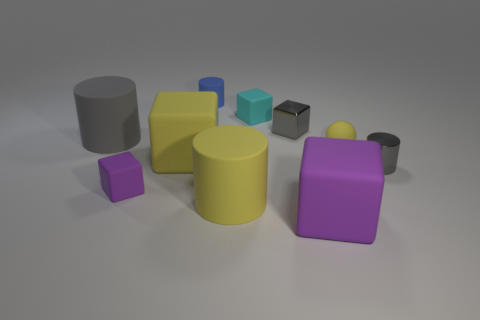How many matte objects have the same color as the shiny block?
Offer a terse response. 1. How many objects are small gray things on the right side of the yellow block or yellow blocks behind the large purple matte block?
Your answer should be very brief. 3. Are there fewer tiny blue rubber cylinders that are on the right side of the big purple cube than small cylinders?
Provide a succinct answer. Yes. Is there a cube of the same size as the blue cylinder?
Ensure brevity in your answer.  Yes. The metallic cylinder has what color?
Keep it short and to the point. Gray. Do the gray matte thing and the yellow cylinder have the same size?
Give a very brief answer. Yes. How many things are either red shiny things or yellow matte objects?
Ensure brevity in your answer.  3. Are there the same number of cylinders to the left of the gray metal block and tiny cyan rubber cylinders?
Your answer should be very brief. No. Are there any rubber cylinders that are in front of the purple object that is on the right side of the tiny cube left of the blue matte thing?
Make the answer very short. No. What color is the small thing that is made of the same material as the tiny gray cylinder?
Keep it short and to the point. Gray. 